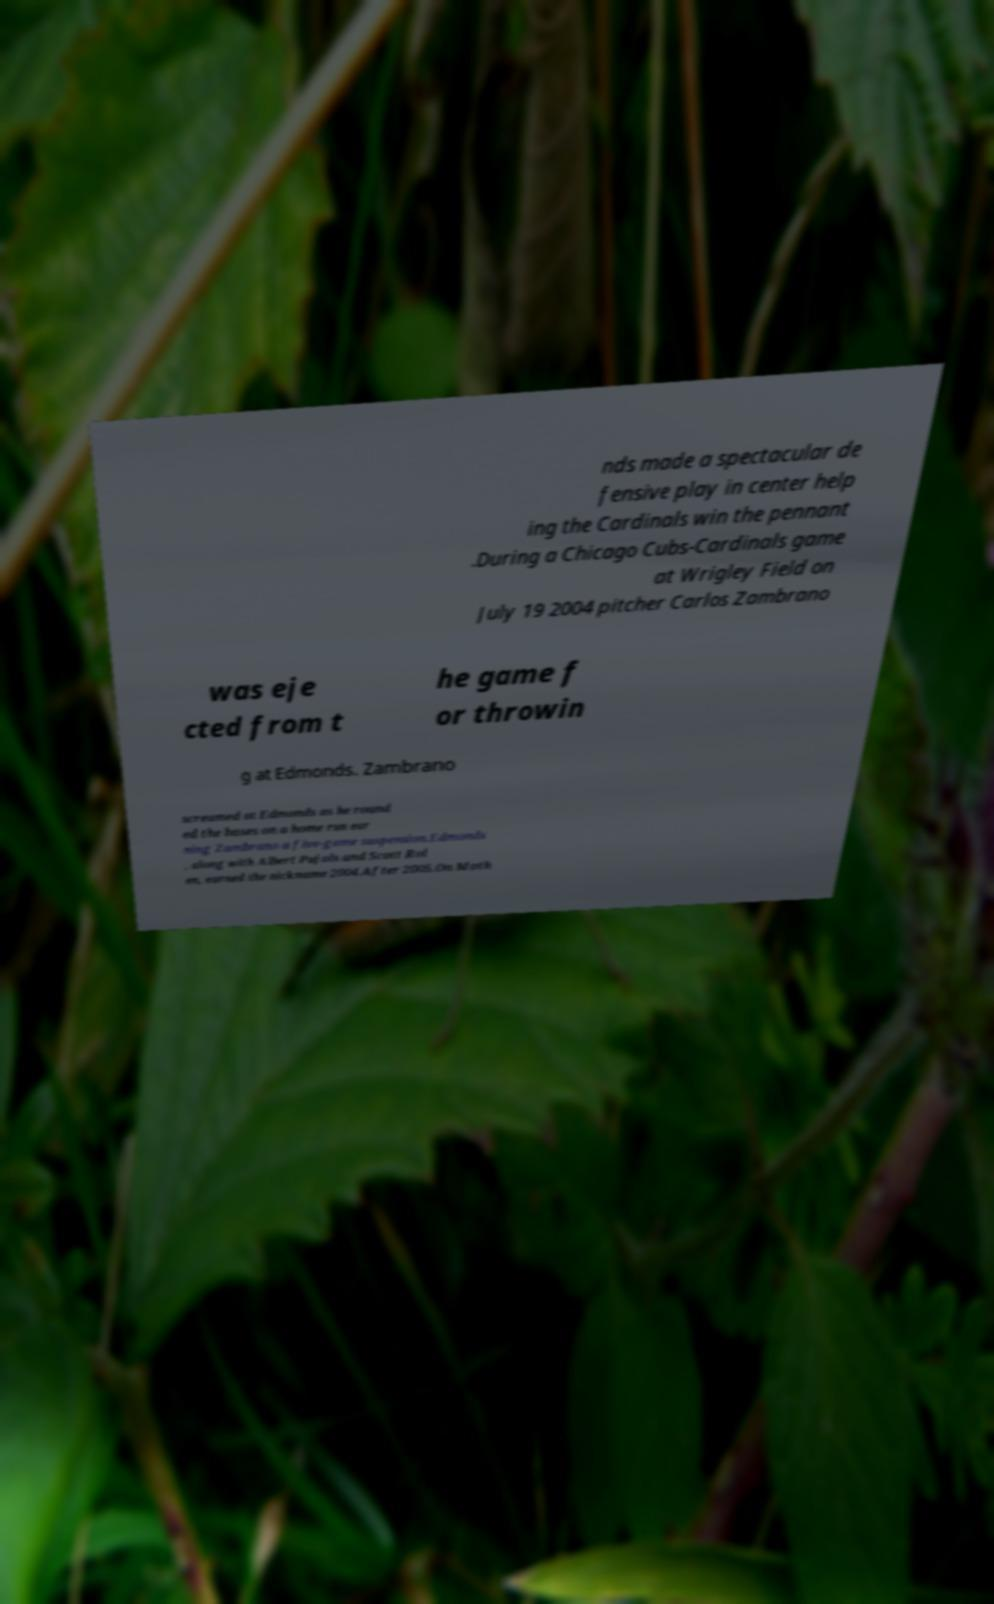I need the written content from this picture converted into text. Can you do that? nds made a spectacular de fensive play in center help ing the Cardinals win the pennant .During a Chicago Cubs-Cardinals game at Wrigley Field on July 19 2004 pitcher Carlos Zambrano was eje cted from t he game f or throwin g at Edmonds. Zambrano screamed at Edmonds as he round ed the bases on a home run ear ning Zambrano a five-game suspension.Edmonds , along with Albert Pujols and Scott Rol en, earned the nickname 2004.After 2005.On Moth 